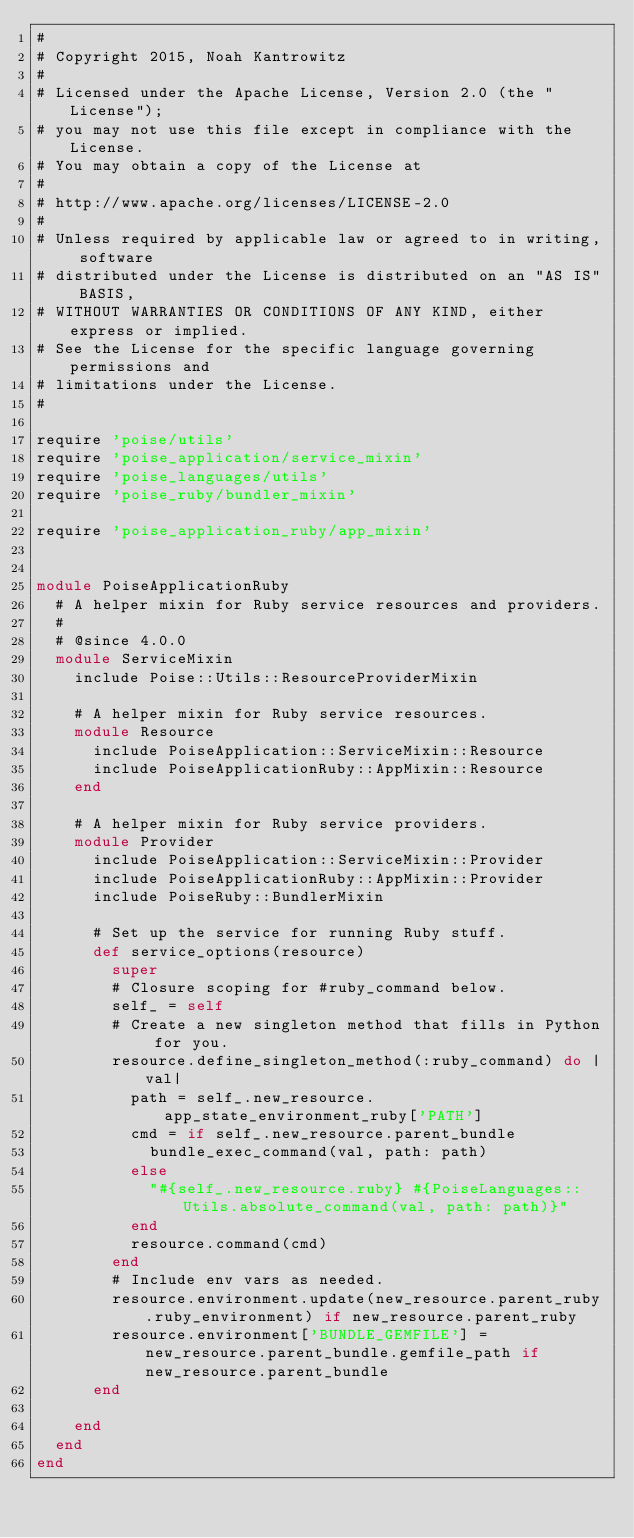<code> <loc_0><loc_0><loc_500><loc_500><_Ruby_>#
# Copyright 2015, Noah Kantrowitz
#
# Licensed under the Apache License, Version 2.0 (the "License");
# you may not use this file except in compliance with the License.
# You may obtain a copy of the License at
#
# http://www.apache.org/licenses/LICENSE-2.0
#
# Unless required by applicable law or agreed to in writing, software
# distributed under the License is distributed on an "AS IS" BASIS,
# WITHOUT WARRANTIES OR CONDITIONS OF ANY KIND, either express or implied.
# See the License for the specific language governing permissions and
# limitations under the License.
#

require 'poise/utils'
require 'poise_application/service_mixin'
require 'poise_languages/utils'
require 'poise_ruby/bundler_mixin'

require 'poise_application_ruby/app_mixin'


module PoiseApplicationRuby
  # A helper mixin for Ruby service resources and providers.
  #
  # @since 4.0.0
  module ServiceMixin
    include Poise::Utils::ResourceProviderMixin

    # A helper mixin for Ruby service resources.
    module Resource
      include PoiseApplication::ServiceMixin::Resource
      include PoiseApplicationRuby::AppMixin::Resource
    end

    # A helper mixin for Ruby service providers.
    module Provider
      include PoiseApplication::ServiceMixin::Provider
      include PoiseApplicationRuby::AppMixin::Provider
      include PoiseRuby::BundlerMixin

      # Set up the service for running Ruby stuff.
      def service_options(resource)
        super
        # Closure scoping for #ruby_command below.
        self_ = self
        # Create a new singleton method that fills in Python for you.
        resource.define_singleton_method(:ruby_command) do |val|
          path = self_.new_resource.app_state_environment_ruby['PATH']
          cmd = if self_.new_resource.parent_bundle
            bundle_exec_command(val, path: path)
          else
            "#{self_.new_resource.ruby} #{PoiseLanguages::Utils.absolute_command(val, path: path)}"
          end
          resource.command(cmd)
        end
        # Include env vars as needed.
        resource.environment.update(new_resource.parent_ruby.ruby_environment) if new_resource.parent_ruby
        resource.environment['BUNDLE_GEMFILE'] = new_resource.parent_bundle.gemfile_path if new_resource.parent_bundle
      end

    end
  end
end
</code> 